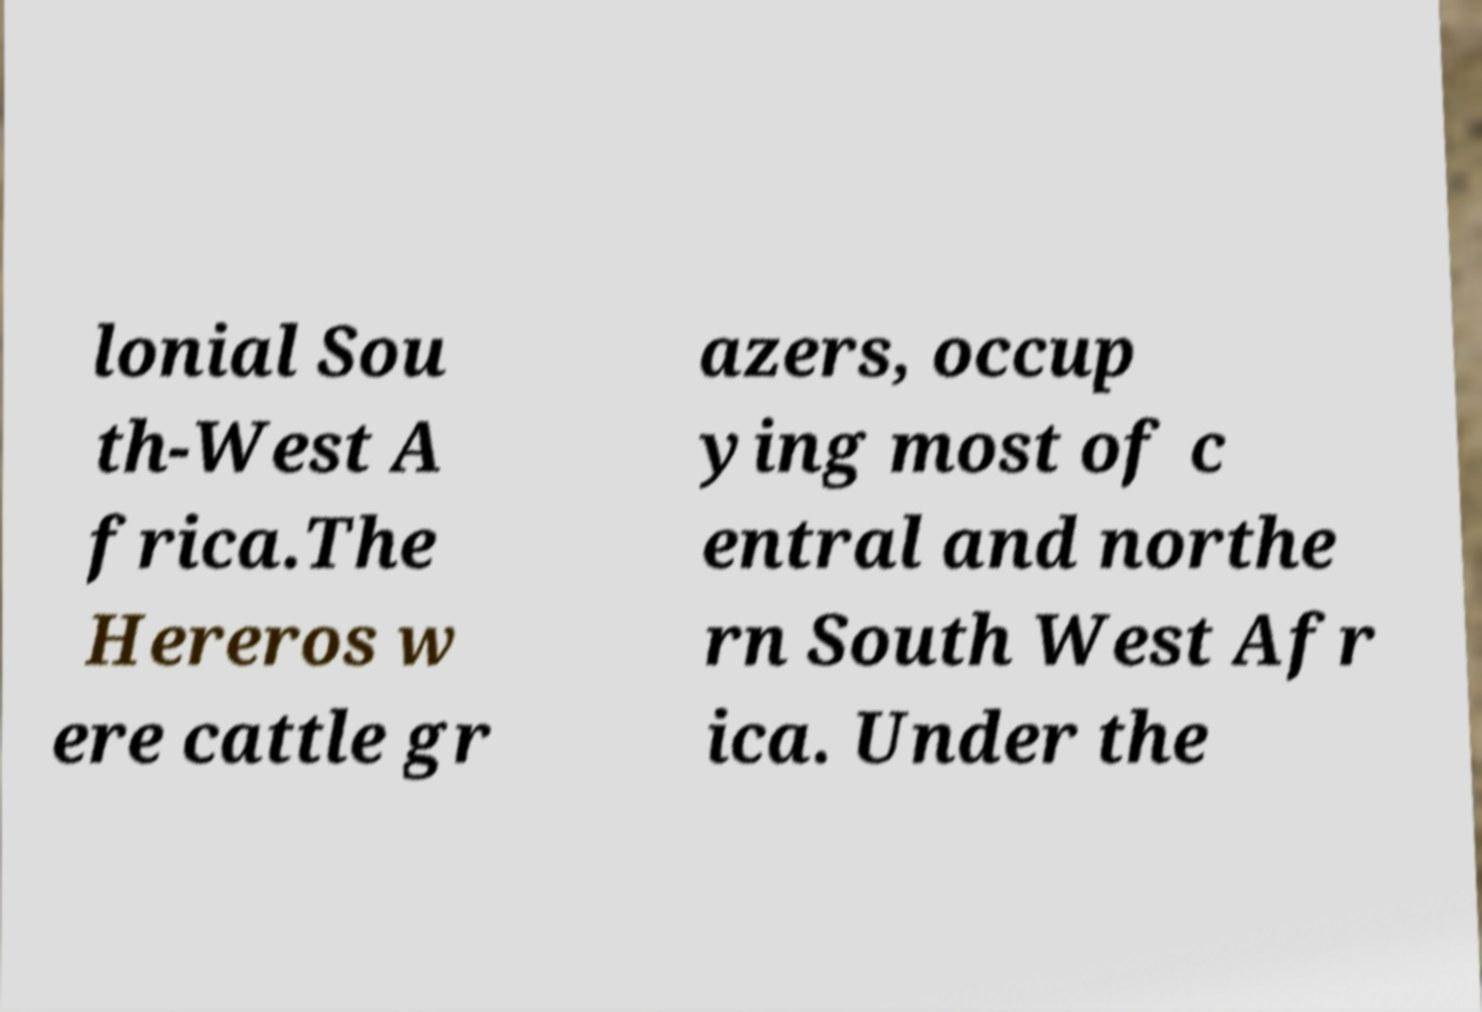Can you read and provide the text displayed in the image?This photo seems to have some interesting text. Can you extract and type it out for me? lonial Sou th-West A frica.The Hereros w ere cattle gr azers, occup ying most of c entral and northe rn South West Afr ica. Under the 